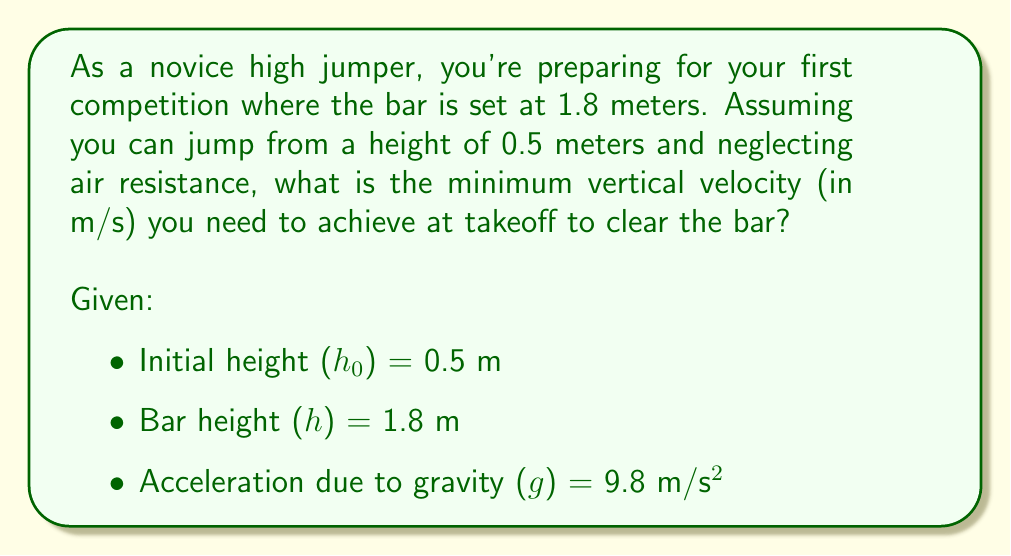Could you help me with this problem? To solve this problem, we'll use the principles of projectile motion, specifically the equation that relates displacement, initial velocity, and acceleration:

$$ h - h_0 = v_0t - \frac{1}{2}gt^2 $$

Where:
- $h - h_0$ is the vertical displacement
- $v_0$ is the initial vertical velocity
- $t$ is the time to reach the highest point
- $g$ is the acceleration due to gravity

Steps to solve:

1) First, calculate the vertical displacement:
   $$ \Delta h = h - h_0 = 1.8 - 0.5 = 1.3 \text{ m} $$

2) At the highest point of the jump, the vertical velocity is zero. We can use this to find the time it takes to reach the highest point:
   $$ v = v_0 - gt $$
   $$ 0 = v_0 - gt $$
   $$ t = \frac{v_0}{g} $$

3) Substitute this expression for $t$ into the displacement equation:
   $$ 1.3 = v_0(\frac{v_0}{g}) - \frac{1}{2}g(\frac{v_0}{g})^2 $$

4) Simplify:
   $$ 1.3 = \frac{v_0^2}{g} - \frac{v_0^2}{2g} = \frac{v_0^2}{2g} $$

5) Solve for $v_0$:
   $$ v_0^2 = 2g(1.3) $$
   $$ v_0 = \sqrt{2g(1.3)} = \sqrt{2(9.8)(1.3)} \approx 5.05 \text{ m/s} $$

Therefore, the minimum vertical velocity needed at takeoff is approximately 5.05 m/s.
Answer: $v_0 \approx 5.05 \text{ m/s}$ 